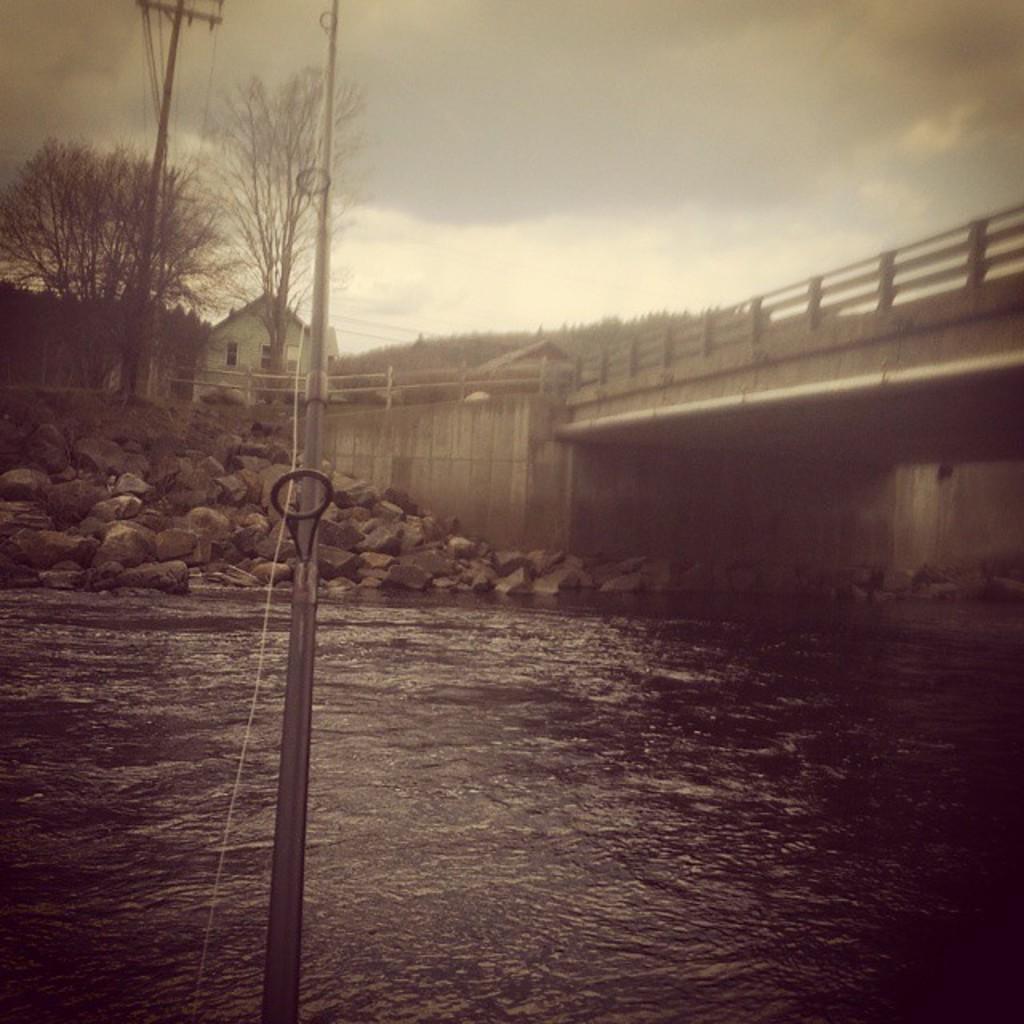Please provide a concise description of this image. In this image we can see a house, there is a bridge, there are rocks, trees, there are poles, wires, also we can see the sky, and the hill. 